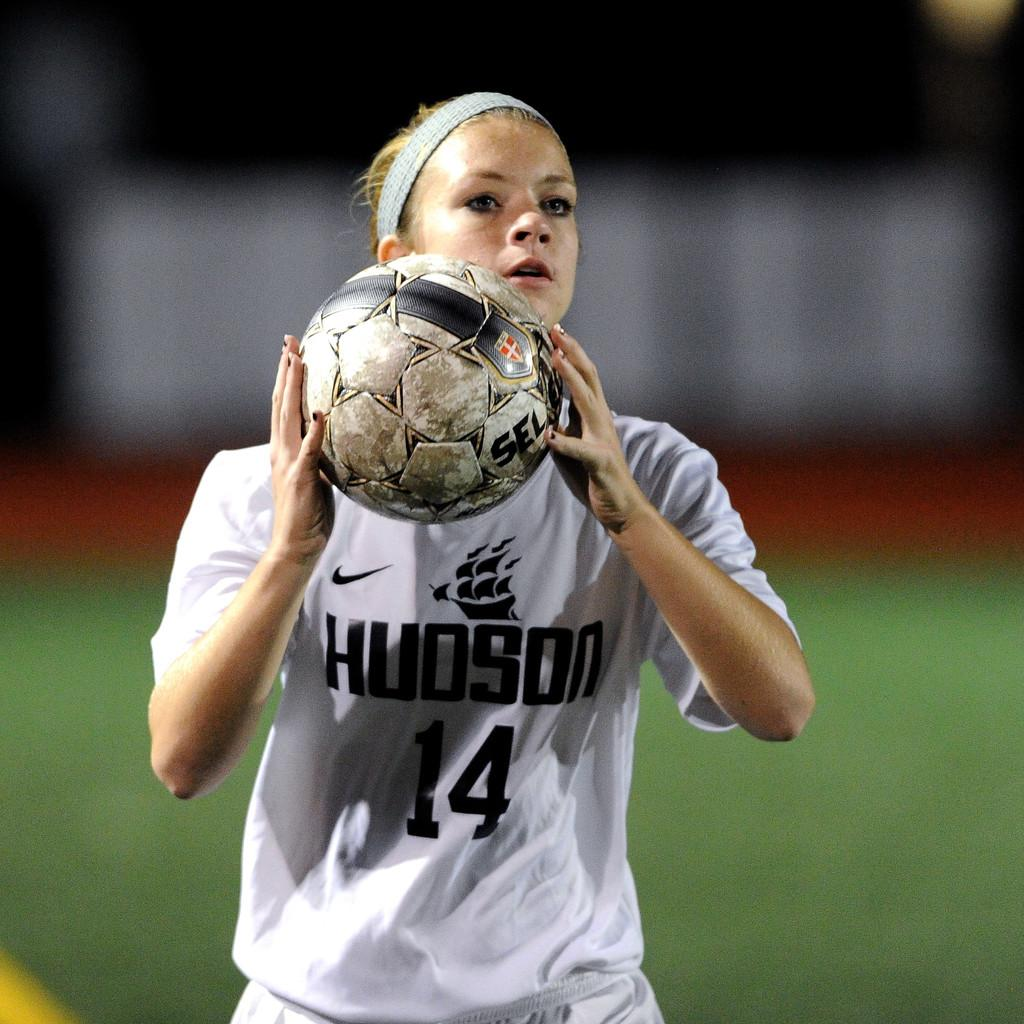<image>
Summarize the visual content of the image. A girl with the number 14 on her jersey is getting ready to throw a soccer ball. 